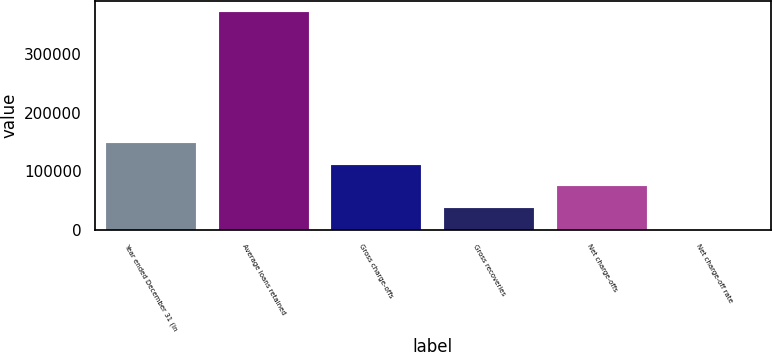Convert chart to OTSL. <chart><loc_0><loc_0><loc_500><loc_500><bar_chart><fcel>Year ended December 31 (in<fcel>Average loans retained<fcel>Gross charge-offs<fcel>Gross recoveries<fcel>Net charge-offs<fcel>Net charge-off rate<nl><fcel>148711<fcel>371778<fcel>111533<fcel>37177.9<fcel>74355.7<fcel>0.09<nl></chart> 